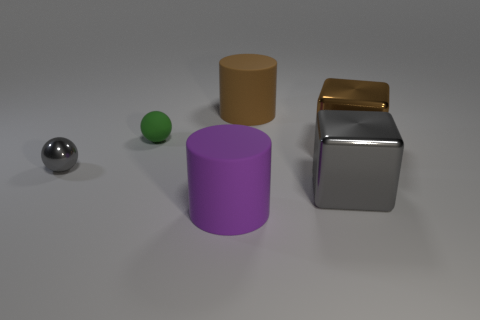Add 2 balls. How many objects exist? 8 Subtract 2 balls. How many balls are left? 0 Subtract all green cylinders. How many gray blocks are left? 1 Subtract all big gray blocks. Subtract all green matte objects. How many objects are left? 4 Add 3 gray metal objects. How many gray metal objects are left? 5 Add 1 big red metal cylinders. How many big red metal cylinders exist? 1 Subtract all gray cubes. How many cubes are left? 1 Subtract 0 red cylinders. How many objects are left? 6 Subtract all spheres. How many objects are left? 4 Subtract all red balls. Subtract all red cubes. How many balls are left? 2 